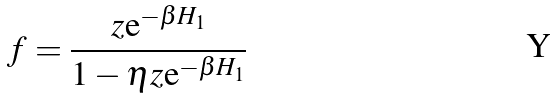<formula> <loc_0><loc_0><loc_500><loc_500>f = \frac { z \text {e} ^ { - \beta H _ { 1 } } } { 1 - \eta z \text {e} ^ { - \beta H _ { 1 } } }</formula> 